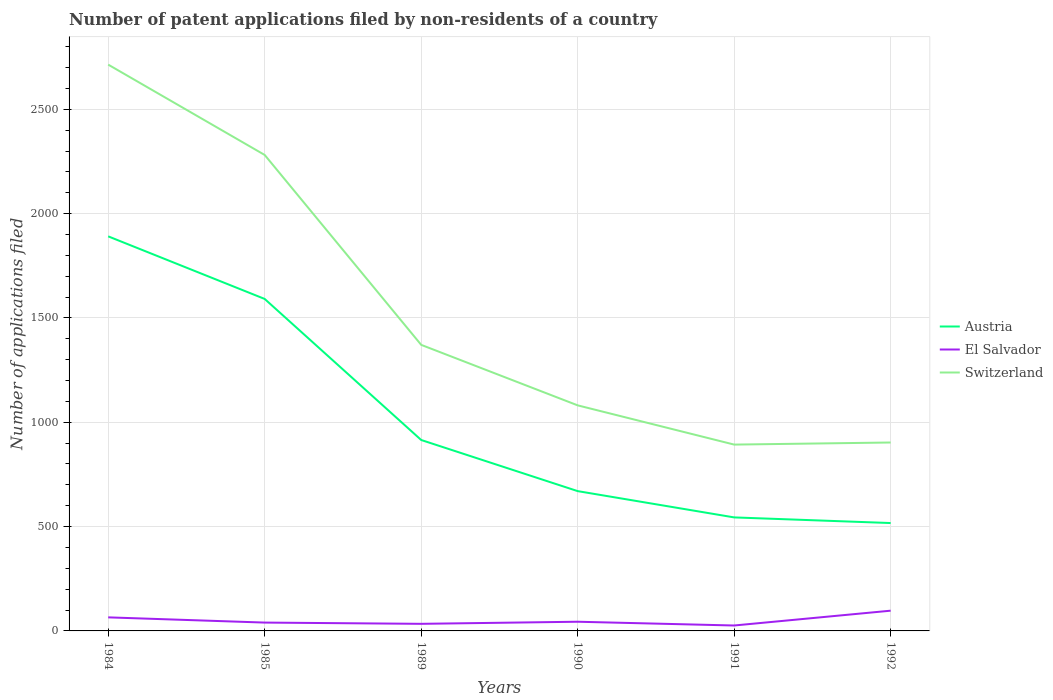How many different coloured lines are there?
Provide a short and direct response. 3. Across all years, what is the maximum number of applications filed in Switzerland?
Offer a very short reply. 893. In which year was the number of applications filed in Austria maximum?
Provide a succinct answer. 1992. What is the total number of applications filed in Austria in the graph?
Ensure brevity in your answer.  245. What is the difference between the highest and the second highest number of applications filed in El Salvador?
Give a very brief answer. 71. Is the number of applications filed in El Salvador strictly greater than the number of applications filed in Switzerland over the years?
Keep it short and to the point. Yes. How many lines are there?
Offer a terse response. 3. How many years are there in the graph?
Your answer should be compact. 6. Are the values on the major ticks of Y-axis written in scientific E-notation?
Give a very brief answer. No. Does the graph contain any zero values?
Provide a succinct answer. No. Does the graph contain grids?
Make the answer very short. Yes. Where does the legend appear in the graph?
Your answer should be compact. Center right. How many legend labels are there?
Offer a terse response. 3. How are the legend labels stacked?
Provide a short and direct response. Vertical. What is the title of the graph?
Offer a very short reply. Number of patent applications filed by non-residents of a country. Does "Belize" appear as one of the legend labels in the graph?
Keep it short and to the point. No. What is the label or title of the Y-axis?
Offer a very short reply. Number of applications filed. What is the Number of applications filed in Austria in 1984?
Keep it short and to the point. 1891. What is the Number of applications filed of El Salvador in 1984?
Your answer should be very brief. 65. What is the Number of applications filed of Switzerland in 1984?
Keep it short and to the point. 2714. What is the Number of applications filed in Austria in 1985?
Keep it short and to the point. 1591. What is the Number of applications filed of El Salvador in 1985?
Your response must be concise. 40. What is the Number of applications filed of Switzerland in 1985?
Offer a very short reply. 2281. What is the Number of applications filed in Austria in 1989?
Offer a very short reply. 915. What is the Number of applications filed of Switzerland in 1989?
Your answer should be very brief. 1371. What is the Number of applications filed in Austria in 1990?
Your response must be concise. 670. What is the Number of applications filed of Switzerland in 1990?
Offer a very short reply. 1081. What is the Number of applications filed in Austria in 1991?
Your answer should be compact. 544. What is the Number of applications filed in El Salvador in 1991?
Keep it short and to the point. 26. What is the Number of applications filed in Switzerland in 1991?
Your response must be concise. 893. What is the Number of applications filed in Austria in 1992?
Give a very brief answer. 517. What is the Number of applications filed of El Salvador in 1992?
Your response must be concise. 97. What is the Number of applications filed in Switzerland in 1992?
Keep it short and to the point. 903. Across all years, what is the maximum Number of applications filed in Austria?
Your answer should be very brief. 1891. Across all years, what is the maximum Number of applications filed of El Salvador?
Make the answer very short. 97. Across all years, what is the maximum Number of applications filed in Switzerland?
Provide a short and direct response. 2714. Across all years, what is the minimum Number of applications filed in Austria?
Give a very brief answer. 517. Across all years, what is the minimum Number of applications filed in El Salvador?
Offer a very short reply. 26. Across all years, what is the minimum Number of applications filed of Switzerland?
Give a very brief answer. 893. What is the total Number of applications filed in Austria in the graph?
Offer a terse response. 6128. What is the total Number of applications filed in El Salvador in the graph?
Your answer should be compact. 306. What is the total Number of applications filed of Switzerland in the graph?
Make the answer very short. 9243. What is the difference between the Number of applications filed in Austria in 1984 and that in 1985?
Your answer should be very brief. 300. What is the difference between the Number of applications filed in Switzerland in 1984 and that in 1985?
Keep it short and to the point. 433. What is the difference between the Number of applications filed in Austria in 1984 and that in 1989?
Ensure brevity in your answer.  976. What is the difference between the Number of applications filed in Switzerland in 1984 and that in 1989?
Provide a short and direct response. 1343. What is the difference between the Number of applications filed of Austria in 1984 and that in 1990?
Give a very brief answer. 1221. What is the difference between the Number of applications filed in Switzerland in 1984 and that in 1990?
Your answer should be compact. 1633. What is the difference between the Number of applications filed of Austria in 1984 and that in 1991?
Give a very brief answer. 1347. What is the difference between the Number of applications filed of Switzerland in 1984 and that in 1991?
Your answer should be very brief. 1821. What is the difference between the Number of applications filed in Austria in 1984 and that in 1992?
Give a very brief answer. 1374. What is the difference between the Number of applications filed of El Salvador in 1984 and that in 1992?
Provide a succinct answer. -32. What is the difference between the Number of applications filed in Switzerland in 1984 and that in 1992?
Your answer should be very brief. 1811. What is the difference between the Number of applications filed of Austria in 1985 and that in 1989?
Your answer should be compact. 676. What is the difference between the Number of applications filed in Switzerland in 1985 and that in 1989?
Offer a terse response. 910. What is the difference between the Number of applications filed in Austria in 1985 and that in 1990?
Provide a short and direct response. 921. What is the difference between the Number of applications filed in El Salvador in 1985 and that in 1990?
Your response must be concise. -4. What is the difference between the Number of applications filed of Switzerland in 1985 and that in 1990?
Your answer should be compact. 1200. What is the difference between the Number of applications filed in Austria in 1985 and that in 1991?
Your response must be concise. 1047. What is the difference between the Number of applications filed in Switzerland in 1985 and that in 1991?
Offer a terse response. 1388. What is the difference between the Number of applications filed in Austria in 1985 and that in 1992?
Your answer should be compact. 1074. What is the difference between the Number of applications filed of El Salvador in 1985 and that in 1992?
Ensure brevity in your answer.  -57. What is the difference between the Number of applications filed of Switzerland in 1985 and that in 1992?
Give a very brief answer. 1378. What is the difference between the Number of applications filed in Austria in 1989 and that in 1990?
Make the answer very short. 245. What is the difference between the Number of applications filed in El Salvador in 1989 and that in 1990?
Your answer should be compact. -10. What is the difference between the Number of applications filed of Switzerland in 1989 and that in 1990?
Provide a short and direct response. 290. What is the difference between the Number of applications filed of Austria in 1989 and that in 1991?
Offer a very short reply. 371. What is the difference between the Number of applications filed of Switzerland in 1989 and that in 1991?
Offer a terse response. 478. What is the difference between the Number of applications filed of Austria in 1989 and that in 1992?
Make the answer very short. 398. What is the difference between the Number of applications filed of El Salvador in 1989 and that in 1992?
Offer a very short reply. -63. What is the difference between the Number of applications filed in Switzerland in 1989 and that in 1992?
Offer a very short reply. 468. What is the difference between the Number of applications filed of Austria in 1990 and that in 1991?
Provide a short and direct response. 126. What is the difference between the Number of applications filed in Switzerland in 1990 and that in 1991?
Offer a terse response. 188. What is the difference between the Number of applications filed of Austria in 1990 and that in 1992?
Provide a short and direct response. 153. What is the difference between the Number of applications filed in El Salvador in 1990 and that in 1992?
Make the answer very short. -53. What is the difference between the Number of applications filed of Switzerland in 1990 and that in 1992?
Provide a short and direct response. 178. What is the difference between the Number of applications filed in El Salvador in 1991 and that in 1992?
Offer a very short reply. -71. What is the difference between the Number of applications filed of Switzerland in 1991 and that in 1992?
Ensure brevity in your answer.  -10. What is the difference between the Number of applications filed in Austria in 1984 and the Number of applications filed in El Salvador in 1985?
Give a very brief answer. 1851. What is the difference between the Number of applications filed of Austria in 1984 and the Number of applications filed of Switzerland in 1985?
Your answer should be compact. -390. What is the difference between the Number of applications filed in El Salvador in 1984 and the Number of applications filed in Switzerland in 1985?
Your response must be concise. -2216. What is the difference between the Number of applications filed of Austria in 1984 and the Number of applications filed of El Salvador in 1989?
Provide a short and direct response. 1857. What is the difference between the Number of applications filed of Austria in 1984 and the Number of applications filed of Switzerland in 1989?
Offer a very short reply. 520. What is the difference between the Number of applications filed of El Salvador in 1984 and the Number of applications filed of Switzerland in 1989?
Provide a short and direct response. -1306. What is the difference between the Number of applications filed of Austria in 1984 and the Number of applications filed of El Salvador in 1990?
Ensure brevity in your answer.  1847. What is the difference between the Number of applications filed in Austria in 1984 and the Number of applications filed in Switzerland in 1990?
Offer a very short reply. 810. What is the difference between the Number of applications filed of El Salvador in 1984 and the Number of applications filed of Switzerland in 1990?
Give a very brief answer. -1016. What is the difference between the Number of applications filed in Austria in 1984 and the Number of applications filed in El Salvador in 1991?
Make the answer very short. 1865. What is the difference between the Number of applications filed of Austria in 1984 and the Number of applications filed of Switzerland in 1991?
Your answer should be compact. 998. What is the difference between the Number of applications filed of El Salvador in 1984 and the Number of applications filed of Switzerland in 1991?
Offer a very short reply. -828. What is the difference between the Number of applications filed in Austria in 1984 and the Number of applications filed in El Salvador in 1992?
Offer a terse response. 1794. What is the difference between the Number of applications filed of Austria in 1984 and the Number of applications filed of Switzerland in 1992?
Ensure brevity in your answer.  988. What is the difference between the Number of applications filed in El Salvador in 1984 and the Number of applications filed in Switzerland in 1992?
Offer a terse response. -838. What is the difference between the Number of applications filed in Austria in 1985 and the Number of applications filed in El Salvador in 1989?
Ensure brevity in your answer.  1557. What is the difference between the Number of applications filed of Austria in 1985 and the Number of applications filed of Switzerland in 1989?
Offer a terse response. 220. What is the difference between the Number of applications filed of El Salvador in 1985 and the Number of applications filed of Switzerland in 1989?
Provide a succinct answer. -1331. What is the difference between the Number of applications filed of Austria in 1985 and the Number of applications filed of El Salvador in 1990?
Offer a very short reply. 1547. What is the difference between the Number of applications filed in Austria in 1985 and the Number of applications filed in Switzerland in 1990?
Your answer should be very brief. 510. What is the difference between the Number of applications filed in El Salvador in 1985 and the Number of applications filed in Switzerland in 1990?
Provide a short and direct response. -1041. What is the difference between the Number of applications filed in Austria in 1985 and the Number of applications filed in El Salvador in 1991?
Your answer should be compact. 1565. What is the difference between the Number of applications filed in Austria in 1985 and the Number of applications filed in Switzerland in 1991?
Your answer should be compact. 698. What is the difference between the Number of applications filed in El Salvador in 1985 and the Number of applications filed in Switzerland in 1991?
Your response must be concise. -853. What is the difference between the Number of applications filed of Austria in 1985 and the Number of applications filed of El Salvador in 1992?
Provide a succinct answer. 1494. What is the difference between the Number of applications filed in Austria in 1985 and the Number of applications filed in Switzerland in 1992?
Offer a terse response. 688. What is the difference between the Number of applications filed of El Salvador in 1985 and the Number of applications filed of Switzerland in 1992?
Provide a short and direct response. -863. What is the difference between the Number of applications filed in Austria in 1989 and the Number of applications filed in El Salvador in 1990?
Provide a succinct answer. 871. What is the difference between the Number of applications filed in Austria in 1989 and the Number of applications filed in Switzerland in 1990?
Offer a terse response. -166. What is the difference between the Number of applications filed in El Salvador in 1989 and the Number of applications filed in Switzerland in 1990?
Make the answer very short. -1047. What is the difference between the Number of applications filed of Austria in 1989 and the Number of applications filed of El Salvador in 1991?
Give a very brief answer. 889. What is the difference between the Number of applications filed in Austria in 1989 and the Number of applications filed in Switzerland in 1991?
Your answer should be compact. 22. What is the difference between the Number of applications filed of El Salvador in 1989 and the Number of applications filed of Switzerland in 1991?
Offer a very short reply. -859. What is the difference between the Number of applications filed in Austria in 1989 and the Number of applications filed in El Salvador in 1992?
Your answer should be very brief. 818. What is the difference between the Number of applications filed of El Salvador in 1989 and the Number of applications filed of Switzerland in 1992?
Offer a terse response. -869. What is the difference between the Number of applications filed of Austria in 1990 and the Number of applications filed of El Salvador in 1991?
Your answer should be compact. 644. What is the difference between the Number of applications filed of Austria in 1990 and the Number of applications filed of Switzerland in 1991?
Your answer should be compact. -223. What is the difference between the Number of applications filed in El Salvador in 1990 and the Number of applications filed in Switzerland in 1991?
Keep it short and to the point. -849. What is the difference between the Number of applications filed in Austria in 1990 and the Number of applications filed in El Salvador in 1992?
Keep it short and to the point. 573. What is the difference between the Number of applications filed in Austria in 1990 and the Number of applications filed in Switzerland in 1992?
Make the answer very short. -233. What is the difference between the Number of applications filed in El Salvador in 1990 and the Number of applications filed in Switzerland in 1992?
Your answer should be very brief. -859. What is the difference between the Number of applications filed in Austria in 1991 and the Number of applications filed in El Salvador in 1992?
Your answer should be compact. 447. What is the difference between the Number of applications filed of Austria in 1991 and the Number of applications filed of Switzerland in 1992?
Your answer should be compact. -359. What is the difference between the Number of applications filed in El Salvador in 1991 and the Number of applications filed in Switzerland in 1992?
Your response must be concise. -877. What is the average Number of applications filed of Austria per year?
Keep it short and to the point. 1021.33. What is the average Number of applications filed of Switzerland per year?
Offer a very short reply. 1540.5. In the year 1984, what is the difference between the Number of applications filed in Austria and Number of applications filed in El Salvador?
Ensure brevity in your answer.  1826. In the year 1984, what is the difference between the Number of applications filed in Austria and Number of applications filed in Switzerland?
Your response must be concise. -823. In the year 1984, what is the difference between the Number of applications filed in El Salvador and Number of applications filed in Switzerland?
Make the answer very short. -2649. In the year 1985, what is the difference between the Number of applications filed of Austria and Number of applications filed of El Salvador?
Offer a very short reply. 1551. In the year 1985, what is the difference between the Number of applications filed of Austria and Number of applications filed of Switzerland?
Your answer should be compact. -690. In the year 1985, what is the difference between the Number of applications filed of El Salvador and Number of applications filed of Switzerland?
Offer a terse response. -2241. In the year 1989, what is the difference between the Number of applications filed of Austria and Number of applications filed of El Salvador?
Give a very brief answer. 881. In the year 1989, what is the difference between the Number of applications filed in Austria and Number of applications filed in Switzerland?
Your answer should be compact. -456. In the year 1989, what is the difference between the Number of applications filed in El Salvador and Number of applications filed in Switzerland?
Your response must be concise. -1337. In the year 1990, what is the difference between the Number of applications filed of Austria and Number of applications filed of El Salvador?
Provide a succinct answer. 626. In the year 1990, what is the difference between the Number of applications filed of Austria and Number of applications filed of Switzerland?
Your response must be concise. -411. In the year 1990, what is the difference between the Number of applications filed of El Salvador and Number of applications filed of Switzerland?
Your response must be concise. -1037. In the year 1991, what is the difference between the Number of applications filed in Austria and Number of applications filed in El Salvador?
Ensure brevity in your answer.  518. In the year 1991, what is the difference between the Number of applications filed in Austria and Number of applications filed in Switzerland?
Offer a very short reply. -349. In the year 1991, what is the difference between the Number of applications filed of El Salvador and Number of applications filed of Switzerland?
Provide a succinct answer. -867. In the year 1992, what is the difference between the Number of applications filed of Austria and Number of applications filed of El Salvador?
Your response must be concise. 420. In the year 1992, what is the difference between the Number of applications filed in Austria and Number of applications filed in Switzerland?
Provide a succinct answer. -386. In the year 1992, what is the difference between the Number of applications filed of El Salvador and Number of applications filed of Switzerland?
Ensure brevity in your answer.  -806. What is the ratio of the Number of applications filed in Austria in 1984 to that in 1985?
Provide a succinct answer. 1.19. What is the ratio of the Number of applications filed in El Salvador in 1984 to that in 1985?
Offer a very short reply. 1.62. What is the ratio of the Number of applications filed of Switzerland in 1984 to that in 1985?
Provide a short and direct response. 1.19. What is the ratio of the Number of applications filed in Austria in 1984 to that in 1989?
Your answer should be very brief. 2.07. What is the ratio of the Number of applications filed of El Salvador in 1984 to that in 1989?
Offer a terse response. 1.91. What is the ratio of the Number of applications filed in Switzerland in 1984 to that in 1989?
Your answer should be compact. 1.98. What is the ratio of the Number of applications filed in Austria in 1984 to that in 1990?
Provide a short and direct response. 2.82. What is the ratio of the Number of applications filed of El Salvador in 1984 to that in 1990?
Give a very brief answer. 1.48. What is the ratio of the Number of applications filed of Switzerland in 1984 to that in 1990?
Make the answer very short. 2.51. What is the ratio of the Number of applications filed of Austria in 1984 to that in 1991?
Keep it short and to the point. 3.48. What is the ratio of the Number of applications filed of Switzerland in 1984 to that in 1991?
Provide a succinct answer. 3.04. What is the ratio of the Number of applications filed in Austria in 1984 to that in 1992?
Your answer should be compact. 3.66. What is the ratio of the Number of applications filed of El Salvador in 1984 to that in 1992?
Your answer should be compact. 0.67. What is the ratio of the Number of applications filed of Switzerland in 1984 to that in 1992?
Ensure brevity in your answer.  3.01. What is the ratio of the Number of applications filed in Austria in 1985 to that in 1989?
Ensure brevity in your answer.  1.74. What is the ratio of the Number of applications filed in El Salvador in 1985 to that in 1989?
Give a very brief answer. 1.18. What is the ratio of the Number of applications filed in Switzerland in 1985 to that in 1989?
Your response must be concise. 1.66. What is the ratio of the Number of applications filed of Austria in 1985 to that in 1990?
Your answer should be very brief. 2.37. What is the ratio of the Number of applications filed of El Salvador in 1985 to that in 1990?
Give a very brief answer. 0.91. What is the ratio of the Number of applications filed of Switzerland in 1985 to that in 1990?
Make the answer very short. 2.11. What is the ratio of the Number of applications filed in Austria in 1985 to that in 1991?
Your response must be concise. 2.92. What is the ratio of the Number of applications filed of El Salvador in 1985 to that in 1991?
Offer a terse response. 1.54. What is the ratio of the Number of applications filed in Switzerland in 1985 to that in 1991?
Ensure brevity in your answer.  2.55. What is the ratio of the Number of applications filed in Austria in 1985 to that in 1992?
Give a very brief answer. 3.08. What is the ratio of the Number of applications filed in El Salvador in 1985 to that in 1992?
Give a very brief answer. 0.41. What is the ratio of the Number of applications filed of Switzerland in 1985 to that in 1992?
Ensure brevity in your answer.  2.53. What is the ratio of the Number of applications filed of Austria in 1989 to that in 1990?
Keep it short and to the point. 1.37. What is the ratio of the Number of applications filed of El Salvador in 1989 to that in 1990?
Give a very brief answer. 0.77. What is the ratio of the Number of applications filed in Switzerland in 1989 to that in 1990?
Keep it short and to the point. 1.27. What is the ratio of the Number of applications filed of Austria in 1989 to that in 1991?
Offer a very short reply. 1.68. What is the ratio of the Number of applications filed of El Salvador in 1989 to that in 1991?
Provide a short and direct response. 1.31. What is the ratio of the Number of applications filed in Switzerland in 1989 to that in 1991?
Your answer should be very brief. 1.54. What is the ratio of the Number of applications filed of Austria in 1989 to that in 1992?
Provide a succinct answer. 1.77. What is the ratio of the Number of applications filed in El Salvador in 1989 to that in 1992?
Offer a very short reply. 0.35. What is the ratio of the Number of applications filed of Switzerland in 1989 to that in 1992?
Give a very brief answer. 1.52. What is the ratio of the Number of applications filed of Austria in 1990 to that in 1991?
Provide a short and direct response. 1.23. What is the ratio of the Number of applications filed of El Salvador in 1990 to that in 1991?
Your response must be concise. 1.69. What is the ratio of the Number of applications filed in Switzerland in 1990 to that in 1991?
Ensure brevity in your answer.  1.21. What is the ratio of the Number of applications filed in Austria in 1990 to that in 1992?
Your response must be concise. 1.3. What is the ratio of the Number of applications filed of El Salvador in 1990 to that in 1992?
Give a very brief answer. 0.45. What is the ratio of the Number of applications filed of Switzerland in 1990 to that in 1992?
Your answer should be very brief. 1.2. What is the ratio of the Number of applications filed of Austria in 1991 to that in 1992?
Give a very brief answer. 1.05. What is the ratio of the Number of applications filed in El Salvador in 1991 to that in 1992?
Your answer should be compact. 0.27. What is the ratio of the Number of applications filed in Switzerland in 1991 to that in 1992?
Offer a terse response. 0.99. What is the difference between the highest and the second highest Number of applications filed of Austria?
Keep it short and to the point. 300. What is the difference between the highest and the second highest Number of applications filed in Switzerland?
Ensure brevity in your answer.  433. What is the difference between the highest and the lowest Number of applications filed in Austria?
Keep it short and to the point. 1374. What is the difference between the highest and the lowest Number of applications filed in El Salvador?
Make the answer very short. 71. What is the difference between the highest and the lowest Number of applications filed of Switzerland?
Your answer should be compact. 1821. 